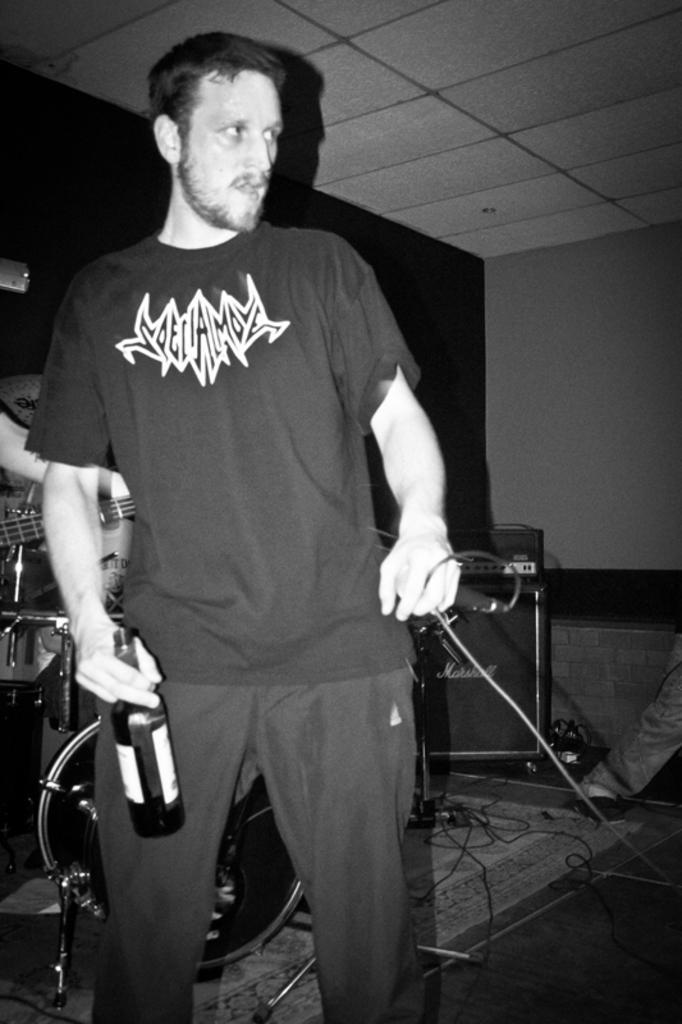Could you give a brief overview of what you see in this image? In this picture we can observe a man standing, holding a bottle in his hand. He is wearing T shirt. He is holding mic in his other hand. In the background there is a speaker and we can observe some musical instruments. There is a wall here. This is a black and white image. 